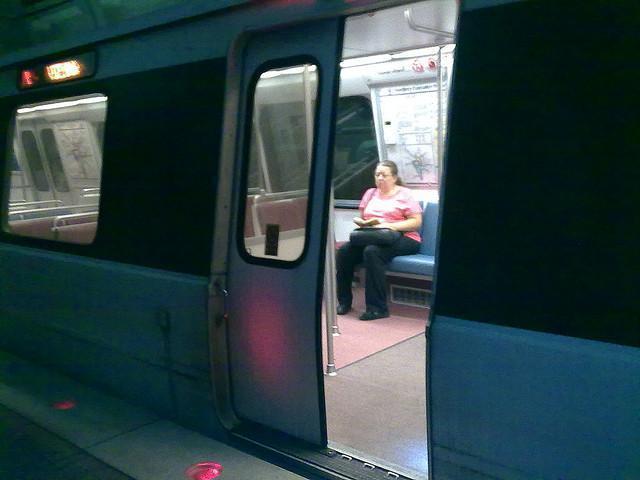How many people are on the train?
Give a very brief answer. 1. How many people ate this cake judging from the forks?
Give a very brief answer. 0. 